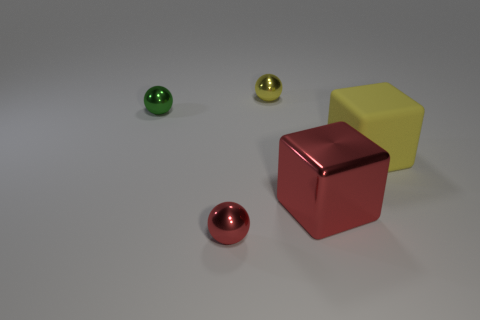How do the objects in the image relate to each other in terms of geometry? The objects in the image provide a comparison of geometric shapes and sizes. There are two spheres of different sizes and two cubes, also differing in size. This juxtaposition may suggest a study of spatial relationships and proportions between geometric forms. 